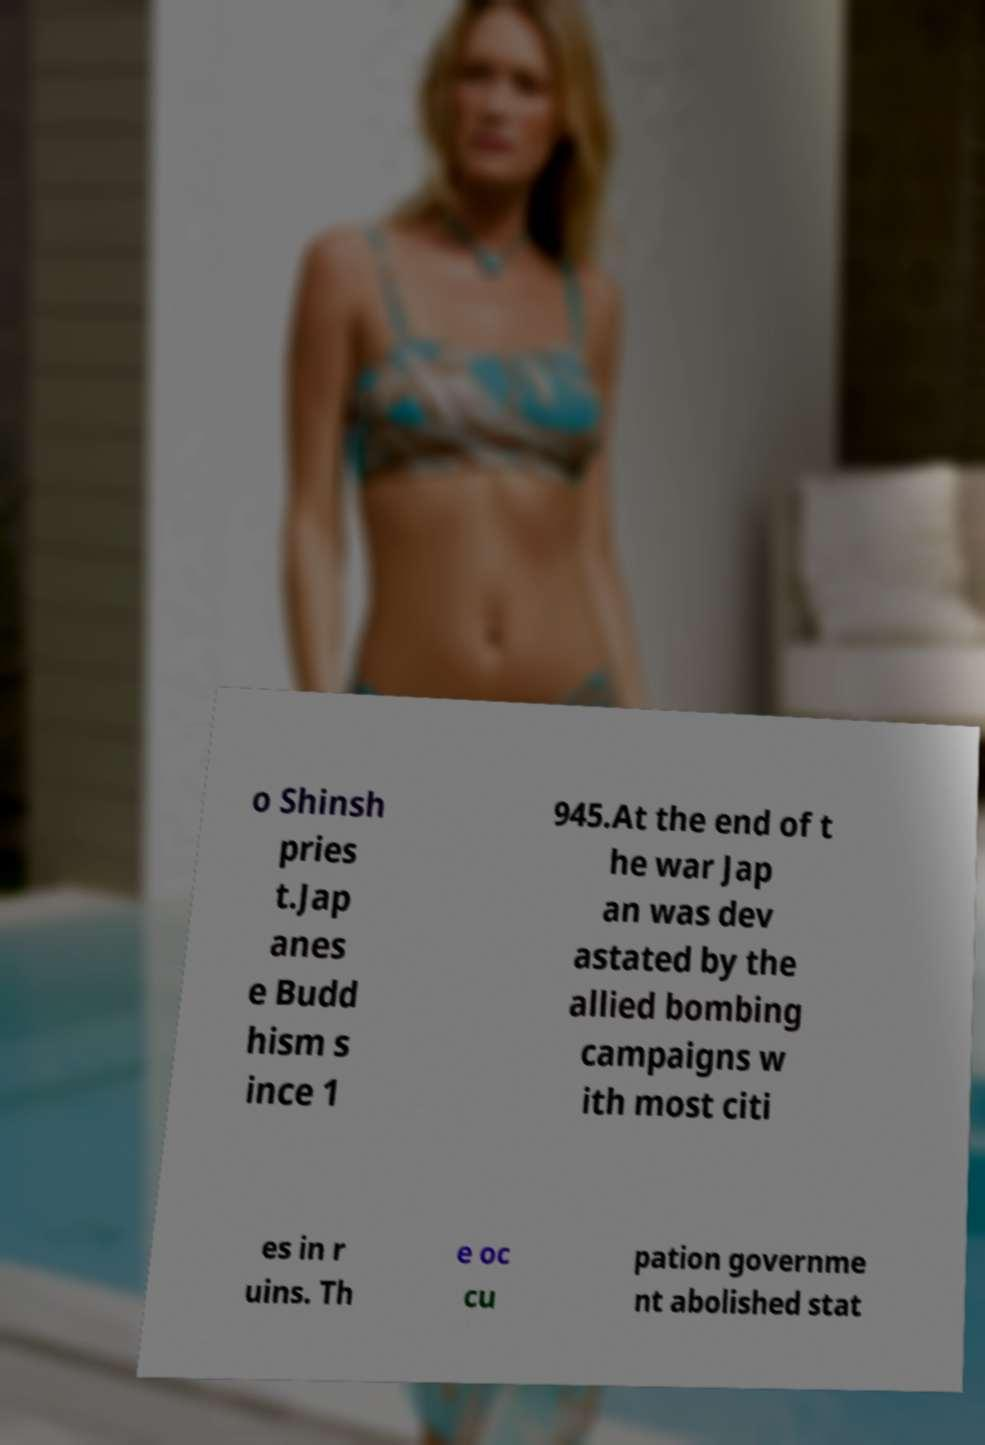For documentation purposes, I need the text within this image transcribed. Could you provide that? o Shinsh pries t.Jap anes e Budd hism s ince 1 945.At the end of t he war Jap an was dev astated by the allied bombing campaigns w ith most citi es in r uins. Th e oc cu pation governme nt abolished stat 